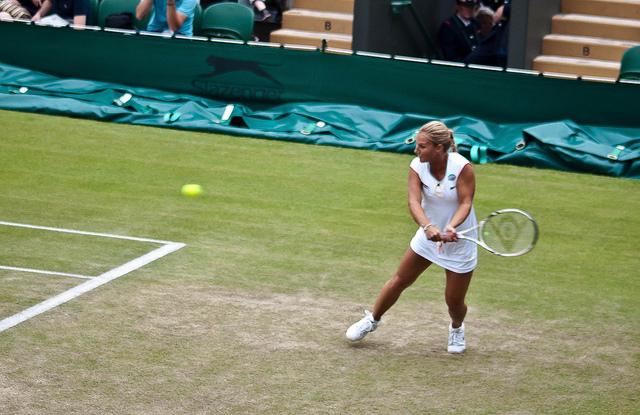What is this person playing?
Answer briefly. Tennis. What race is the athlete?
Quick response, please. White. Is the athlete male or female?
Short answer required. Female. 